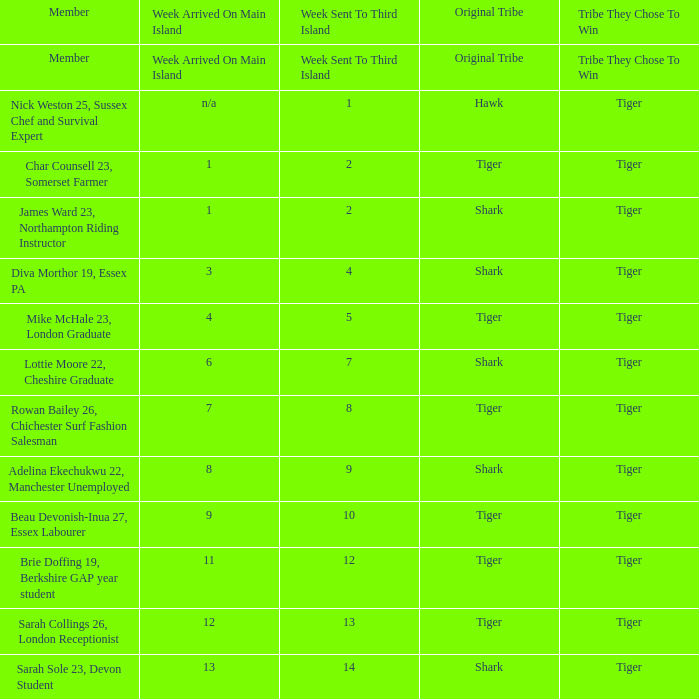During the fourth week, how many members arrived on the main island? 1.0. 